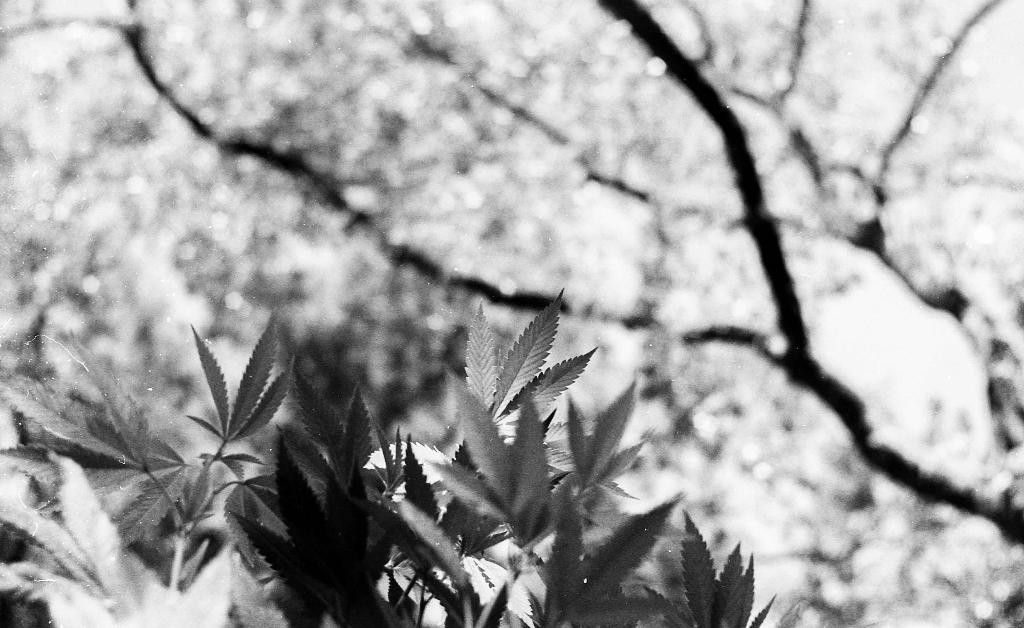What is the color scheme of the image? The image is black and white. What type of vegetation can be seen in the image? There are plants and trees in the image. What type of religious request is being made in the image? There is no religious request present in the image; it only features plants and trees in a black and white color scheme. Can you locate the map in the image? There is no map present in the image; it only features plants and trees in a black and white color scheme. 